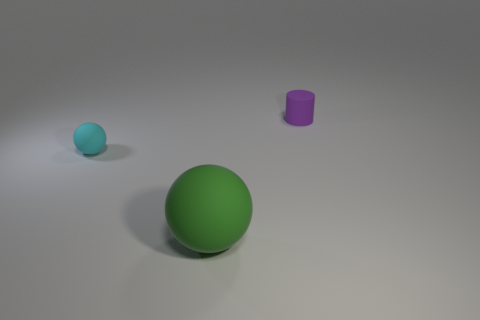Is there any other thing that has the same size as the green rubber ball?
Make the answer very short. No. There is a rubber cylinder; how many tiny things are to the right of it?
Your answer should be compact. 0. There is a cylinder that is made of the same material as the large green object; what is its color?
Make the answer very short. Purple. What number of matte objects are purple objects or tiny blue objects?
Your answer should be compact. 1. Do the cylinder and the large object have the same material?
Your answer should be compact. Yes. What shape is the small object on the left side of the green matte object?
Your response must be concise. Sphere. There is a small thing that is behind the cyan sphere; are there any things left of it?
Ensure brevity in your answer.  Yes. Is there a gray matte thing that has the same size as the purple rubber cylinder?
Your response must be concise. No. Does the tiny object left of the large green object have the same color as the small cylinder?
Offer a very short reply. No. What is the size of the cyan object?
Your answer should be compact. Small. 